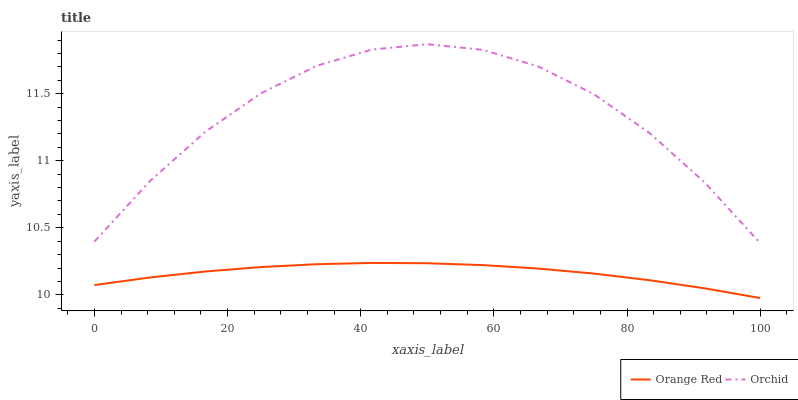Does Orange Red have the minimum area under the curve?
Answer yes or no. Yes. Does Orchid have the maximum area under the curve?
Answer yes or no. Yes. Does Orchid have the minimum area under the curve?
Answer yes or no. No. Is Orange Red the smoothest?
Answer yes or no. Yes. Is Orchid the roughest?
Answer yes or no. Yes. Is Orchid the smoothest?
Answer yes or no. No. Does Orange Red have the lowest value?
Answer yes or no. Yes. Does Orchid have the lowest value?
Answer yes or no. No. Does Orchid have the highest value?
Answer yes or no. Yes. Is Orange Red less than Orchid?
Answer yes or no. Yes. Is Orchid greater than Orange Red?
Answer yes or no. Yes. Does Orange Red intersect Orchid?
Answer yes or no. No. 